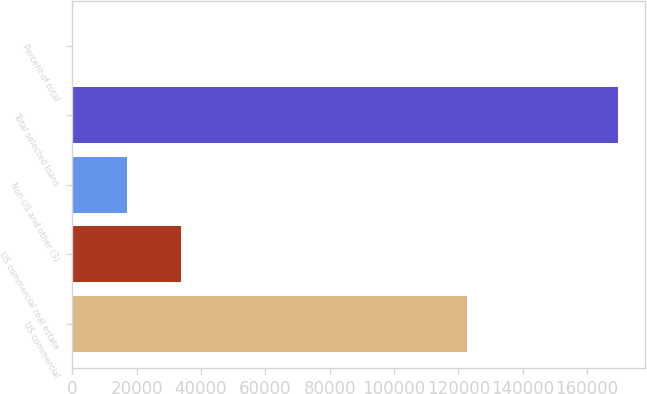Convert chart. <chart><loc_0><loc_0><loc_500><loc_500><bar_chart><fcel>US commercial<fcel>US commercial real estate<fcel>Non-US and other (3)<fcel>Total selected loans<fcel>Percent of total<nl><fcel>122739<fcel>33955<fcel>17000.5<fcel>169591<fcel>46<nl></chart> 